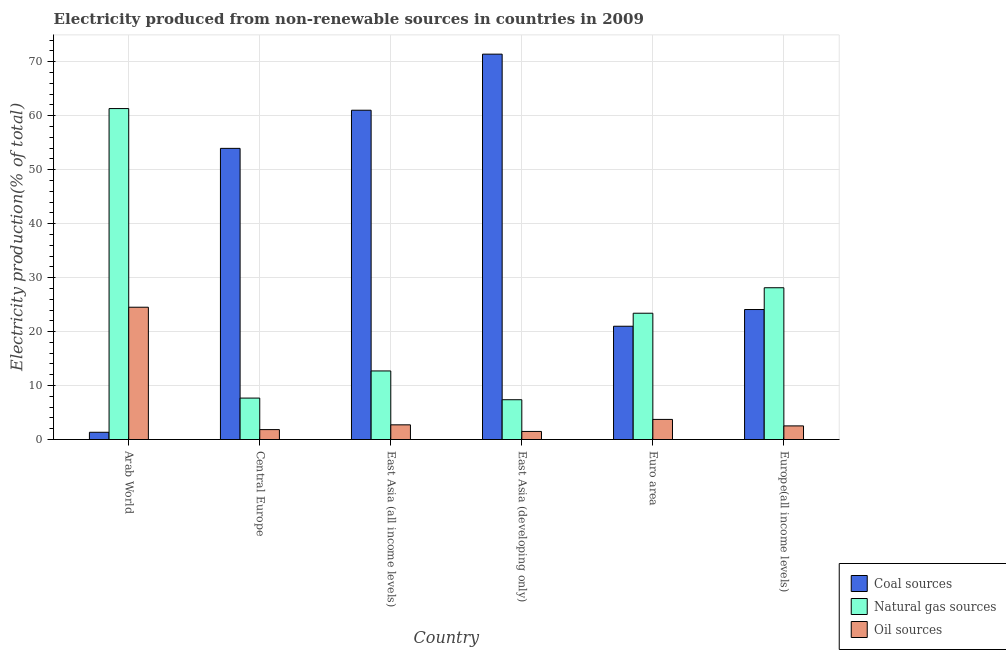Are the number of bars on each tick of the X-axis equal?
Keep it short and to the point. Yes. How many bars are there on the 1st tick from the left?
Your answer should be compact. 3. How many bars are there on the 1st tick from the right?
Make the answer very short. 3. What is the label of the 6th group of bars from the left?
Give a very brief answer. Europe(all income levels). What is the percentage of electricity produced by natural gas in East Asia (all income levels)?
Your answer should be very brief. 12.71. Across all countries, what is the maximum percentage of electricity produced by oil sources?
Your answer should be very brief. 24.51. Across all countries, what is the minimum percentage of electricity produced by oil sources?
Your answer should be compact. 1.5. In which country was the percentage of electricity produced by coal maximum?
Your answer should be very brief. East Asia (developing only). In which country was the percentage of electricity produced by coal minimum?
Your answer should be very brief. Arab World. What is the total percentage of electricity produced by coal in the graph?
Offer a terse response. 232.81. What is the difference between the percentage of electricity produced by coal in East Asia (all income levels) and that in East Asia (developing only)?
Provide a short and direct response. -10.39. What is the difference between the percentage of electricity produced by coal in Euro area and the percentage of electricity produced by natural gas in East Asia (all income levels)?
Your answer should be very brief. 8.28. What is the average percentage of electricity produced by oil sources per country?
Your answer should be very brief. 6.14. What is the difference between the percentage of electricity produced by coal and percentage of electricity produced by oil sources in East Asia (developing only)?
Keep it short and to the point. 69.92. In how many countries, is the percentage of electricity produced by coal greater than 8 %?
Provide a succinct answer. 5. What is the ratio of the percentage of electricity produced by coal in East Asia (developing only) to that in Euro area?
Give a very brief answer. 3.4. Is the percentage of electricity produced by natural gas in Arab World less than that in East Asia (developing only)?
Make the answer very short. No. Is the difference between the percentage of electricity produced by oil sources in Central Europe and East Asia (developing only) greater than the difference between the percentage of electricity produced by natural gas in Central Europe and East Asia (developing only)?
Your answer should be compact. Yes. What is the difference between the highest and the second highest percentage of electricity produced by oil sources?
Make the answer very short. 20.79. What is the difference between the highest and the lowest percentage of electricity produced by coal?
Keep it short and to the point. 70.07. Is the sum of the percentage of electricity produced by oil sources in East Asia (developing only) and Europe(all income levels) greater than the maximum percentage of electricity produced by natural gas across all countries?
Offer a terse response. No. What does the 2nd bar from the left in Europe(all income levels) represents?
Provide a short and direct response. Natural gas sources. What does the 2nd bar from the right in Arab World represents?
Offer a terse response. Natural gas sources. Is it the case that in every country, the sum of the percentage of electricity produced by coal and percentage of electricity produced by natural gas is greater than the percentage of electricity produced by oil sources?
Ensure brevity in your answer.  Yes. How many bars are there?
Your answer should be very brief. 18. Are all the bars in the graph horizontal?
Offer a very short reply. No. Where does the legend appear in the graph?
Give a very brief answer. Bottom right. What is the title of the graph?
Your answer should be very brief. Electricity produced from non-renewable sources in countries in 2009. What is the label or title of the X-axis?
Your answer should be very brief. Country. What is the label or title of the Y-axis?
Offer a terse response. Electricity production(% of total). What is the Electricity production(% of total) in Coal sources in Arab World?
Ensure brevity in your answer.  1.34. What is the Electricity production(% of total) in Natural gas sources in Arab World?
Offer a very short reply. 61.33. What is the Electricity production(% of total) of Oil sources in Arab World?
Make the answer very short. 24.51. What is the Electricity production(% of total) in Coal sources in Central Europe?
Provide a succinct answer. 53.95. What is the Electricity production(% of total) in Natural gas sources in Central Europe?
Give a very brief answer. 7.68. What is the Electricity production(% of total) of Oil sources in Central Europe?
Offer a very short reply. 1.84. What is the Electricity production(% of total) in Coal sources in East Asia (all income levels)?
Your answer should be very brief. 61.02. What is the Electricity production(% of total) of Natural gas sources in East Asia (all income levels)?
Provide a short and direct response. 12.71. What is the Electricity production(% of total) of Oil sources in East Asia (all income levels)?
Offer a very short reply. 2.72. What is the Electricity production(% of total) in Coal sources in East Asia (developing only)?
Offer a terse response. 71.41. What is the Electricity production(% of total) in Natural gas sources in East Asia (developing only)?
Offer a terse response. 7.37. What is the Electricity production(% of total) in Oil sources in East Asia (developing only)?
Make the answer very short. 1.5. What is the Electricity production(% of total) in Coal sources in Euro area?
Offer a very short reply. 20.99. What is the Electricity production(% of total) in Natural gas sources in Euro area?
Make the answer very short. 23.4. What is the Electricity production(% of total) in Oil sources in Euro area?
Your response must be concise. 3.72. What is the Electricity production(% of total) in Coal sources in Europe(all income levels)?
Provide a short and direct response. 24.09. What is the Electricity production(% of total) of Natural gas sources in Europe(all income levels)?
Ensure brevity in your answer.  28.12. What is the Electricity production(% of total) of Oil sources in Europe(all income levels)?
Keep it short and to the point. 2.52. Across all countries, what is the maximum Electricity production(% of total) in Coal sources?
Keep it short and to the point. 71.41. Across all countries, what is the maximum Electricity production(% of total) in Natural gas sources?
Your answer should be compact. 61.33. Across all countries, what is the maximum Electricity production(% of total) of Oil sources?
Offer a very short reply. 24.51. Across all countries, what is the minimum Electricity production(% of total) in Coal sources?
Offer a very short reply. 1.34. Across all countries, what is the minimum Electricity production(% of total) in Natural gas sources?
Your answer should be compact. 7.37. Across all countries, what is the minimum Electricity production(% of total) in Oil sources?
Provide a succinct answer. 1.5. What is the total Electricity production(% of total) in Coal sources in the graph?
Keep it short and to the point. 232.81. What is the total Electricity production(% of total) in Natural gas sources in the graph?
Your answer should be compact. 140.61. What is the total Electricity production(% of total) in Oil sources in the graph?
Provide a short and direct response. 36.82. What is the difference between the Electricity production(% of total) of Coal sources in Arab World and that in Central Europe?
Provide a succinct answer. -52.61. What is the difference between the Electricity production(% of total) of Natural gas sources in Arab World and that in Central Europe?
Provide a short and direct response. 53.65. What is the difference between the Electricity production(% of total) in Oil sources in Arab World and that in Central Europe?
Your response must be concise. 22.68. What is the difference between the Electricity production(% of total) of Coal sources in Arab World and that in East Asia (all income levels)?
Offer a very short reply. -59.68. What is the difference between the Electricity production(% of total) in Natural gas sources in Arab World and that in East Asia (all income levels)?
Your answer should be compact. 48.62. What is the difference between the Electricity production(% of total) of Oil sources in Arab World and that in East Asia (all income levels)?
Keep it short and to the point. 21.79. What is the difference between the Electricity production(% of total) in Coal sources in Arab World and that in East Asia (developing only)?
Give a very brief answer. -70.07. What is the difference between the Electricity production(% of total) in Natural gas sources in Arab World and that in East Asia (developing only)?
Give a very brief answer. 53.95. What is the difference between the Electricity production(% of total) in Oil sources in Arab World and that in East Asia (developing only)?
Keep it short and to the point. 23.02. What is the difference between the Electricity production(% of total) in Coal sources in Arab World and that in Euro area?
Keep it short and to the point. -19.65. What is the difference between the Electricity production(% of total) of Natural gas sources in Arab World and that in Euro area?
Offer a terse response. 37.92. What is the difference between the Electricity production(% of total) in Oil sources in Arab World and that in Euro area?
Offer a very short reply. 20.79. What is the difference between the Electricity production(% of total) in Coal sources in Arab World and that in Europe(all income levels)?
Give a very brief answer. -22.75. What is the difference between the Electricity production(% of total) in Natural gas sources in Arab World and that in Europe(all income levels)?
Ensure brevity in your answer.  33.2. What is the difference between the Electricity production(% of total) of Oil sources in Arab World and that in Europe(all income levels)?
Make the answer very short. 21.99. What is the difference between the Electricity production(% of total) of Coal sources in Central Europe and that in East Asia (all income levels)?
Offer a very short reply. -7.07. What is the difference between the Electricity production(% of total) in Natural gas sources in Central Europe and that in East Asia (all income levels)?
Offer a terse response. -5.03. What is the difference between the Electricity production(% of total) in Oil sources in Central Europe and that in East Asia (all income levels)?
Offer a very short reply. -0.88. What is the difference between the Electricity production(% of total) of Coal sources in Central Europe and that in East Asia (developing only)?
Your response must be concise. -17.46. What is the difference between the Electricity production(% of total) of Natural gas sources in Central Europe and that in East Asia (developing only)?
Provide a succinct answer. 0.3. What is the difference between the Electricity production(% of total) of Oil sources in Central Europe and that in East Asia (developing only)?
Ensure brevity in your answer.  0.34. What is the difference between the Electricity production(% of total) of Coal sources in Central Europe and that in Euro area?
Offer a terse response. 32.96. What is the difference between the Electricity production(% of total) of Natural gas sources in Central Europe and that in Euro area?
Offer a terse response. -15.72. What is the difference between the Electricity production(% of total) in Oil sources in Central Europe and that in Euro area?
Your answer should be very brief. -1.89. What is the difference between the Electricity production(% of total) in Coal sources in Central Europe and that in Europe(all income levels)?
Provide a succinct answer. 29.86. What is the difference between the Electricity production(% of total) in Natural gas sources in Central Europe and that in Europe(all income levels)?
Offer a very short reply. -20.45. What is the difference between the Electricity production(% of total) in Oil sources in Central Europe and that in Europe(all income levels)?
Provide a short and direct response. -0.69. What is the difference between the Electricity production(% of total) of Coal sources in East Asia (all income levels) and that in East Asia (developing only)?
Your answer should be very brief. -10.39. What is the difference between the Electricity production(% of total) of Natural gas sources in East Asia (all income levels) and that in East Asia (developing only)?
Ensure brevity in your answer.  5.34. What is the difference between the Electricity production(% of total) of Oil sources in East Asia (all income levels) and that in East Asia (developing only)?
Your answer should be compact. 1.23. What is the difference between the Electricity production(% of total) of Coal sources in East Asia (all income levels) and that in Euro area?
Provide a succinct answer. 40.03. What is the difference between the Electricity production(% of total) of Natural gas sources in East Asia (all income levels) and that in Euro area?
Provide a short and direct response. -10.69. What is the difference between the Electricity production(% of total) in Oil sources in East Asia (all income levels) and that in Euro area?
Your response must be concise. -1. What is the difference between the Electricity production(% of total) of Coal sources in East Asia (all income levels) and that in Europe(all income levels)?
Offer a very short reply. 36.93. What is the difference between the Electricity production(% of total) in Natural gas sources in East Asia (all income levels) and that in Europe(all income levels)?
Give a very brief answer. -15.42. What is the difference between the Electricity production(% of total) of Oil sources in East Asia (all income levels) and that in Europe(all income levels)?
Your answer should be compact. 0.2. What is the difference between the Electricity production(% of total) in Coal sources in East Asia (developing only) and that in Euro area?
Offer a very short reply. 50.42. What is the difference between the Electricity production(% of total) of Natural gas sources in East Asia (developing only) and that in Euro area?
Offer a very short reply. -16.03. What is the difference between the Electricity production(% of total) in Oil sources in East Asia (developing only) and that in Euro area?
Give a very brief answer. -2.23. What is the difference between the Electricity production(% of total) in Coal sources in East Asia (developing only) and that in Europe(all income levels)?
Offer a very short reply. 47.32. What is the difference between the Electricity production(% of total) of Natural gas sources in East Asia (developing only) and that in Europe(all income levels)?
Your answer should be very brief. -20.75. What is the difference between the Electricity production(% of total) of Oil sources in East Asia (developing only) and that in Europe(all income levels)?
Your answer should be compact. -1.03. What is the difference between the Electricity production(% of total) in Coal sources in Euro area and that in Europe(all income levels)?
Make the answer very short. -3.1. What is the difference between the Electricity production(% of total) in Natural gas sources in Euro area and that in Europe(all income levels)?
Your response must be concise. -4.72. What is the difference between the Electricity production(% of total) in Oil sources in Euro area and that in Europe(all income levels)?
Keep it short and to the point. 1.2. What is the difference between the Electricity production(% of total) of Coal sources in Arab World and the Electricity production(% of total) of Natural gas sources in Central Europe?
Ensure brevity in your answer.  -6.33. What is the difference between the Electricity production(% of total) in Coal sources in Arab World and the Electricity production(% of total) in Oil sources in Central Europe?
Keep it short and to the point. -0.49. What is the difference between the Electricity production(% of total) in Natural gas sources in Arab World and the Electricity production(% of total) in Oil sources in Central Europe?
Provide a short and direct response. 59.49. What is the difference between the Electricity production(% of total) in Coal sources in Arab World and the Electricity production(% of total) in Natural gas sources in East Asia (all income levels)?
Give a very brief answer. -11.36. What is the difference between the Electricity production(% of total) in Coal sources in Arab World and the Electricity production(% of total) in Oil sources in East Asia (all income levels)?
Your answer should be compact. -1.38. What is the difference between the Electricity production(% of total) in Natural gas sources in Arab World and the Electricity production(% of total) in Oil sources in East Asia (all income levels)?
Give a very brief answer. 58.6. What is the difference between the Electricity production(% of total) of Coal sources in Arab World and the Electricity production(% of total) of Natural gas sources in East Asia (developing only)?
Your answer should be very brief. -6.03. What is the difference between the Electricity production(% of total) of Coal sources in Arab World and the Electricity production(% of total) of Oil sources in East Asia (developing only)?
Offer a very short reply. -0.15. What is the difference between the Electricity production(% of total) of Natural gas sources in Arab World and the Electricity production(% of total) of Oil sources in East Asia (developing only)?
Your response must be concise. 59.83. What is the difference between the Electricity production(% of total) of Coal sources in Arab World and the Electricity production(% of total) of Natural gas sources in Euro area?
Provide a short and direct response. -22.06. What is the difference between the Electricity production(% of total) of Coal sources in Arab World and the Electricity production(% of total) of Oil sources in Euro area?
Provide a short and direct response. -2.38. What is the difference between the Electricity production(% of total) in Natural gas sources in Arab World and the Electricity production(% of total) in Oil sources in Euro area?
Ensure brevity in your answer.  57.6. What is the difference between the Electricity production(% of total) in Coal sources in Arab World and the Electricity production(% of total) in Natural gas sources in Europe(all income levels)?
Provide a succinct answer. -26.78. What is the difference between the Electricity production(% of total) of Coal sources in Arab World and the Electricity production(% of total) of Oil sources in Europe(all income levels)?
Offer a very short reply. -1.18. What is the difference between the Electricity production(% of total) in Natural gas sources in Arab World and the Electricity production(% of total) in Oil sources in Europe(all income levels)?
Provide a succinct answer. 58.8. What is the difference between the Electricity production(% of total) in Coal sources in Central Europe and the Electricity production(% of total) in Natural gas sources in East Asia (all income levels)?
Offer a very short reply. 41.24. What is the difference between the Electricity production(% of total) of Coal sources in Central Europe and the Electricity production(% of total) of Oil sources in East Asia (all income levels)?
Offer a very short reply. 51.23. What is the difference between the Electricity production(% of total) of Natural gas sources in Central Europe and the Electricity production(% of total) of Oil sources in East Asia (all income levels)?
Offer a very short reply. 4.96. What is the difference between the Electricity production(% of total) in Coal sources in Central Europe and the Electricity production(% of total) in Natural gas sources in East Asia (developing only)?
Give a very brief answer. 46.58. What is the difference between the Electricity production(% of total) of Coal sources in Central Europe and the Electricity production(% of total) of Oil sources in East Asia (developing only)?
Give a very brief answer. 52.46. What is the difference between the Electricity production(% of total) in Natural gas sources in Central Europe and the Electricity production(% of total) in Oil sources in East Asia (developing only)?
Your answer should be very brief. 6.18. What is the difference between the Electricity production(% of total) of Coal sources in Central Europe and the Electricity production(% of total) of Natural gas sources in Euro area?
Give a very brief answer. 30.55. What is the difference between the Electricity production(% of total) in Coal sources in Central Europe and the Electricity production(% of total) in Oil sources in Euro area?
Your response must be concise. 50.23. What is the difference between the Electricity production(% of total) in Natural gas sources in Central Europe and the Electricity production(% of total) in Oil sources in Euro area?
Keep it short and to the point. 3.95. What is the difference between the Electricity production(% of total) of Coal sources in Central Europe and the Electricity production(% of total) of Natural gas sources in Europe(all income levels)?
Your answer should be very brief. 25.83. What is the difference between the Electricity production(% of total) of Coal sources in Central Europe and the Electricity production(% of total) of Oil sources in Europe(all income levels)?
Provide a succinct answer. 51.43. What is the difference between the Electricity production(% of total) of Natural gas sources in Central Europe and the Electricity production(% of total) of Oil sources in Europe(all income levels)?
Make the answer very short. 5.15. What is the difference between the Electricity production(% of total) in Coal sources in East Asia (all income levels) and the Electricity production(% of total) in Natural gas sources in East Asia (developing only)?
Give a very brief answer. 53.65. What is the difference between the Electricity production(% of total) of Coal sources in East Asia (all income levels) and the Electricity production(% of total) of Oil sources in East Asia (developing only)?
Keep it short and to the point. 59.52. What is the difference between the Electricity production(% of total) in Natural gas sources in East Asia (all income levels) and the Electricity production(% of total) in Oil sources in East Asia (developing only)?
Your answer should be very brief. 11.21. What is the difference between the Electricity production(% of total) in Coal sources in East Asia (all income levels) and the Electricity production(% of total) in Natural gas sources in Euro area?
Give a very brief answer. 37.62. What is the difference between the Electricity production(% of total) of Coal sources in East Asia (all income levels) and the Electricity production(% of total) of Oil sources in Euro area?
Your answer should be very brief. 57.29. What is the difference between the Electricity production(% of total) in Natural gas sources in East Asia (all income levels) and the Electricity production(% of total) in Oil sources in Euro area?
Your answer should be very brief. 8.98. What is the difference between the Electricity production(% of total) in Coal sources in East Asia (all income levels) and the Electricity production(% of total) in Natural gas sources in Europe(all income levels)?
Your answer should be very brief. 32.9. What is the difference between the Electricity production(% of total) in Coal sources in East Asia (all income levels) and the Electricity production(% of total) in Oil sources in Europe(all income levels)?
Make the answer very short. 58.5. What is the difference between the Electricity production(% of total) in Natural gas sources in East Asia (all income levels) and the Electricity production(% of total) in Oil sources in Europe(all income levels)?
Your answer should be very brief. 10.19. What is the difference between the Electricity production(% of total) in Coal sources in East Asia (developing only) and the Electricity production(% of total) in Natural gas sources in Euro area?
Your answer should be compact. 48.01. What is the difference between the Electricity production(% of total) of Coal sources in East Asia (developing only) and the Electricity production(% of total) of Oil sources in Euro area?
Make the answer very short. 67.69. What is the difference between the Electricity production(% of total) of Natural gas sources in East Asia (developing only) and the Electricity production(% of total) of Oil sources in Euro area?
Ensure brevity in your answer.  3.65. What is the difference between the Electricity production(% of total) of Coal sources in East Asia (developing only) and the Electricity production(% of total) of Natural gas sources in Europe(all income levels)?
Provide a succinct answer. 43.29. What is the difference between the Electricity production(% of total) in Coal sources in East Asia (developing only) and the Electricity production(% of total) in Oil sources in Europe(all income levels)?
Your answer should be compact. 68.89. What is the difference between the Electricity production(% of total) of Natural gas sources in East Asia (developing only) and the Electricity production(% of total) of Oil sources in Europe(all income levels)?
Provide a succinct answer. 4.85. What is the difference between the Electricity production(% of total) in Coal sources in Euro area and the Electricity production(% of total) in Natural gas sources in Europe(all income levels)?
Your response must be concise. -7.13. What is the difference between the Electricity production(% of total) in Coal sources in Euro area and the Electricity production(% of total) in Oil sources in Europe(all income levels)?
Your answer should be compact. 18.47. What is the difference between the Electricity production(% of total) of Natural gas sources in Euro area and the Electricity production(% of total) of Oil sources in Europe(all income levels)?
Provide a succinct answer. 20.88. What is the average Electricity production(% of total) of Coal sources per country?
Make the answer very short. 38.8. What is the average Electricity production(% of total) of Natural gas sources per country?
Your answer should be very brief. 23.43. What is the average Electricity production(% of total) in Oil sources per country?
Keep it short and to the point. 6.14. What is the difference between the Electricity production(% of total) in Coal sources and Electricity production(% of total) in Natural gas sources in Arab World?
Make the answer very short. -59.98. What is the difference between the Electricity production(% of total) of Coal sources and Electricity production(% of total) of Oil sources in Arab World?
Give a very brief answer. -23.17. What is the difference between the Electricity production(% of total) of Natural gas sources and Electricity production(% of total) of Oil sources in Arab World?
Make the answer very short. 36.81. What is the difference between the Electricity production(% of total) in Coal sources and Electricity production(% of total) in Natural gas sources in Central Europe?
Your answer should be compact. 46.28. What is the difference between the Electricity production(% of total) of Coal sources and Electricity production(% of total) of Oil sources in Central Europe?
Your answer should be very brief. 52.12. What is the difference between the Electricity production(% of total) in Natural gas sources and Electricity production(% of total) in Oil sources in Central Europe?
Give a very brief answer. 5.84. What is the difference between the Electricity production(% of total) in Coal sources and Electricity production(% of total) in Natural gas sources in East Asia (all income levels)?
Ensure brevity in your answer.  48.31. What is the difference between the Electricity production(% of total) in Coal sources and Electricity production(% of total) in Oil sources in East Asia (all income levels)?
Your response must be concise. 58.3. What is the difference between the Electricity production(% of total) in Natural gas sources and Electricity production(% of total) in Oil sources in East Asia (all income levels)?
Give a very brief answer. 9.99. What is the difference between the Electricity production(% of total) of Coal sources and Electricity production(% of total) of Natural gas sources in East Asia (developing only)?
Offer a very short reply. 64.04. What is the difference between the Electricity production(% of total) in Coal sources and Electricity production(% of total) in Oil sources in East Asia (developing only)?
Give a very brief answer. 69.92. What is the difference between the Electricity production(% of total) in Natural gas sources and Electricity production(% of total) in Oil sources in East Asia (developing only)?
Your answer should be very brief. 5.88. What is the difference between the Electricity production(% of total) in Coal sources and Electricity production(% of total) in Natural gas sources in Euro area?
Provide a short and direct response. -2.41. What is the difference between the Electricity production(% of total) of Coal sources and Electricity production(% of total) of Oil sources in Euro area?
Give a very brief answer. 17.27. What is the difference between the Electricity production(% of total) of Natural gas sources and Electricity production(% of total) of Oil sources in Euro area?
Your answer should be very brief. 19.68. What is the difference between the Electricity production(% of total) of Coal sources and Electricity production(% of total) of Natural gas sources in Europe(all income levels)?
Keep it short and to the point. -4.03. What is the difference between the Electricity production(% of total) in Coal sources and Electricity production(% of total) in Oil sources in Europe(all income levels)?
Offer a terse response. 21.57. What is the difference between the Electricity production(% of total) in Natural gas sources and Electricity production(% of total) in Oil sources in Europe(all income levels)?
Offer a terse response. 25.6. What is the ratio of the Electricity production(% of total) of Coal sources in Arab World to that in Central Europe?
Offer a very short reply. 0.02. What is the ratio of the Electricity production(% of total) in Natural gas sources in Arab World to that in Central Europe?
Keep it short and to the point. 7.99. What is the ratio of the Electricity production(% of total) in Oil sources in Arab World to that in Central Europe?
Keep it short and to the point. 13.34. What is the ratio of the Electricity production(% of total) in Coal sources in Arab World to that in East Asia (all income levels)?
Your response must be concise. 0.02. What is the ratio of the Electricity production(% of total) in Natural gas sources in Arab World to that in East Asia (all income levels)?
Your answer should be very brief. 4.83. What is the ratio of the Electricity production(% of total) of Oil sources in Arab World to that in East Asia (all income levels)?
Give a very brief answer. 9.01. What is the ratio of the Electricity production(% of total) of Coal sources in Arab World to that in East Asia (developing only)?
Give a very brief answer. 0.02. What is the ratio of the Electricity production(% of total) of Natural gas sources in Arab World to that in East Asia (developing only)?
Provide a succinct answer. 8.32. What is the ratio of the Electricity production(% of total) of Oil sources in Arab World to that in East Asia (developing only)?
Your answer should be very brief. 16.39. What is the ratio of the Electricity production(% of total) of Coal sources in Arab World to that in Euro area?
Give a very brief answer. 0.06. What is the ratio of the Electricity production(% of total) of Natural gas sources in Arab World to that in Euro area?
Provide a short and direct response. 2.62. What is the ratio of the Electricity production(% of total) of Oil sources in Arab World to that in Euro area?
Your answer should be very brief. 6.58. What is the ratio of the Electricity production(% of total) of Coal sources in Arab World to that in Europe(all income levels)?
Give a very brief answer. 0.06. What is the ratio of the Electricity production(% of total) of Natural gas sources in Arab World to that in Europe(all income levels)?
Offer a very short reply. 2.18. What is the ratio of the Electricity production(% of total) of Oil sources in Arab World to that in Europe(all income levels)?
Ensure brevity in your answer.  9.72. What is the ratio of the Electricity production(% of total) in Coal sources in Central Europe to that in East Asia (all income levels)?
Your response must be concise. 0.88. What is the ratio of the Electricity production(% of total) of Natural gas sources in Central Europe to that in East Asia (all income levels)?
Offer a terse response. 0.6. What is the ratio of the Electricity production(% of total) in Oil sources in Central Europe to that in East Asia (all income levels)?
Make the answer very short. 0.68. What is the ratio of the Electricity production(% of total) in Coal sources in Central Europe to that in East Asia (developing only)?
Your answer should be compact. 0.76. What is the ratio of the Electricity production(% of total) of Natural gas sources in Central Europe to that in East Asia (developing only)?
Provide a succinct answer. 1.04. What is the ratio of the Electricity production(% of total) in Oil sources in Central Europe to that in East Asia (developing only)?
Your answer should be very brief. 1.23. What is the ratio of the Electricity production(% of total) of Coal sources in Central Europe to that in Euro area?
Keep it short and to the point. 2.57. What is the ratio of the Electricity production(% of total) in Natural gas sources in Central Europe to that in Euro area?
Offer a terse response. 0.33. What is the ratio of the Electricity production(% of total) in Oil sources in Central Europe to that in Euro area?
Ensure brevity in your answer.  0.49. What is the ratio of the Electricity production(% of total) of Coal sources in Central Europe to that in Europe(all income levels)?
Your answer should be very brief. 2.24. What is the ratio of the Electricity production(% of total) in Natural gas sources in Central Europe to that in Europe(all income levels)?
Your answer should be very brief. 0.27. What is the ratio of the Electricity production(% of total) in Oil sources in Central Europe to that in Europe(all income levels)?
Ensure brevity in your answer.  0.73. What is the ratio of the Electricity production(% of total) in Coal sources in East Asia (all income levels) to that in East Asia (developing only)?
Your response must be concise. 0.85. What is the ratio of the Electricity production(% of total) in Natural gas sources in East Asia (all income levels) to that in East Asia (developing only)?
Your response must be concise. 1.72. What is the ratio of the Electricity production(% of total) of Oil sources in East Asia (all income levels) to that in East Asia (developing only)?
Offer a terse response. 1.82. What is the ratio of the Electricity production(% of total) of Coal sources in East Asia (all income levels) to that in Euro area?
Your answer should be very brief. 2.91. What is the ratio of the Electricity production(% of total) of Natural gas sources in East Asia (all income levels) to that in Euro area?
Your answer should be compact. 0.54. What is the ratio of the Electricity production(% of total) of Oil sources in East Asia (all income levels) to that in Euro area?
Give a very brief answer. 0.73. What is the ratio of the Electricity production(% of total) in Coal sources in East Asia (all income levels) to that in Europe(all income levels)?
Offer a terse response. 2.53. What is the ratio of the Electricity production(% of total) in Natural gas sources in East Asia (all income levels) to that in Europe(all income levels)?
Provide a succinct answer. 0.45. What is the ratio of the Electricity production(% of total) in Oil sources in East Asia (all income levels) to that in Europe(all income levels)?
Your answer should be very brief. 1.08. What is the ratio of the Electricity production(% of total) of Coal sources in East Asia (developing only) to that in Euro area?
Give a very brief answer. 3.4. What is the ratio of the Electricity production(% of total) in Natural gas sources in East Asia (developing only) to that in Euro area?
Offer a terse response. 0.32. What is the ratio of the Electricity production(% of total) of Oil sources in East Asia (developing only) to that in Euro area?
Your answer should be compact. 0.4. What is the ratio of the Electricity production(% of total) in Coal sources in East Asia (developing only) to that in Europe(all income levels)?
Your response must be concise. 2.96. What is the ratio of the Electricity production(% of total) of Natural gas sources in East Asia (developing only) to that in Europe(all income levels)?
Provide a short and direct response. 0.26. What is the ratio of the Electricity production(% of total) of Oil sources in East Asia (developing only) to that in Europe(all income levels)?
Make the answer very short. 0.59. What is the ratio of the Electricity production(% of total) of Coal sources in Euro area to that in Europe(all income levels)?
Ensure brevity in your answer.  0.87. What is the ratio of the Electricity production(% of total) of Natural gas sources in Euro area to that in Europe(all income levels)?
Provide a succinct answer. 0.83. What is the ratio of the Electricity production(% of total) in Oil sources in Euro area to that in Europe(all income levels)?
Make the answer very short. 1.48. What is the difference between the highest and the second highest Electricity production(% of total) of Coal sources?
Your response must be concise. 10.39. What is the difference between the highest and the second highest Electricity production(% of total) of Natural gas sources?
Your answer should be very brief. 33.2. What is the difference between the highest and the second highest Electricity production(% of total) of Oil sources?
Ensure brevity in your answer.  20.79. What is the difference between the highest and the lowest Electricity production(% of total) of Coal sources?
Ensure brevity in your answer.  70.07. What is the difference between the highest and the lowest Electricity production(% of total) in Natural gas sources?
Ensure brevity in your answer.  53.95. What is the difference between the highest and the lowest Electricity production(% of total) in Oil sources?
Keep it short and to the point. 23.02. 